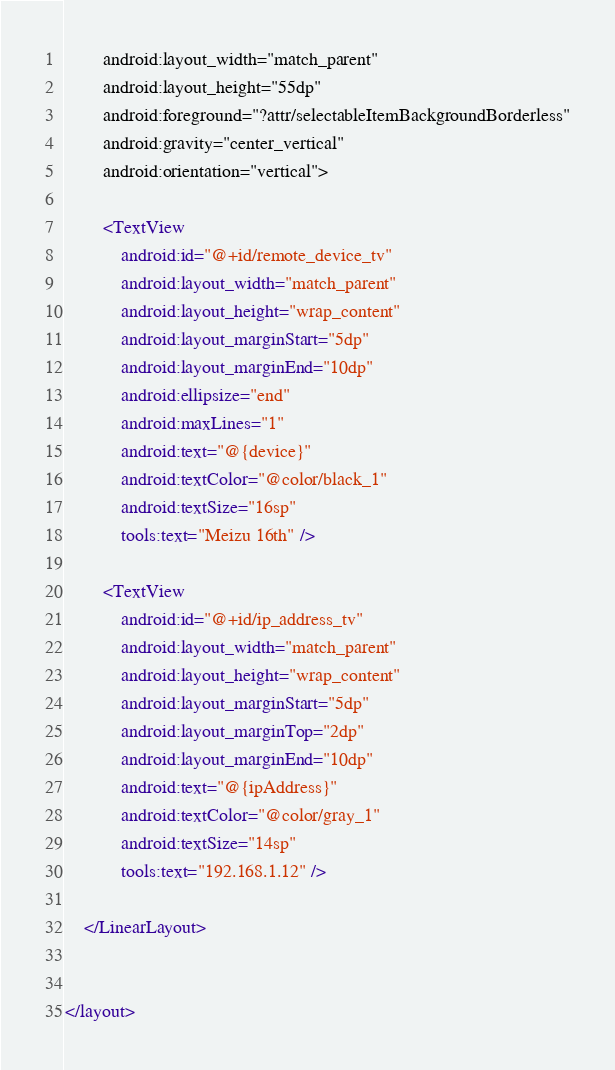<code> <loc_0><loc_0><loc_500><loc_500><_XML_>        android:layout_width="match_parent"
        android:layout_height="55dp"
        android:foreground="?attr/selectableItemBackgroundBorderless"
        android:gravity="center_vertical"
        android:orientation="vertical">

        <TextView
            android:id="@+id/remote_device_tv"
            android:layout_width="match_parent"
            android:layout_height="wrap_content"
            android:layout_marginStart="5dp"
            android:layout_marginEnd="10dp"
            android:ellipsize="end"
            android:maxLines="1"
            android:text="@{device}"
            android:textColor="@color/black_1"
            android:textSize="16sp"
            tools:text="Meizu 16th" />

        <TextView
            android:id="@+id/ip_address_tv"
            android:layout_width="match_parent"
            android:layout_height="wrap_content"
            android:layout_marginStart="5dp"
            android:layout_marginTop="2dp"
            android:layout_marginEnd="10dp"
            android:text="@{ipAddress}"
            android:textColor="@color/gray_1"
            android:textSize="14sp"
            tools:text="192.168.1.12" />

    </LinearLayout>


</layout></code> 